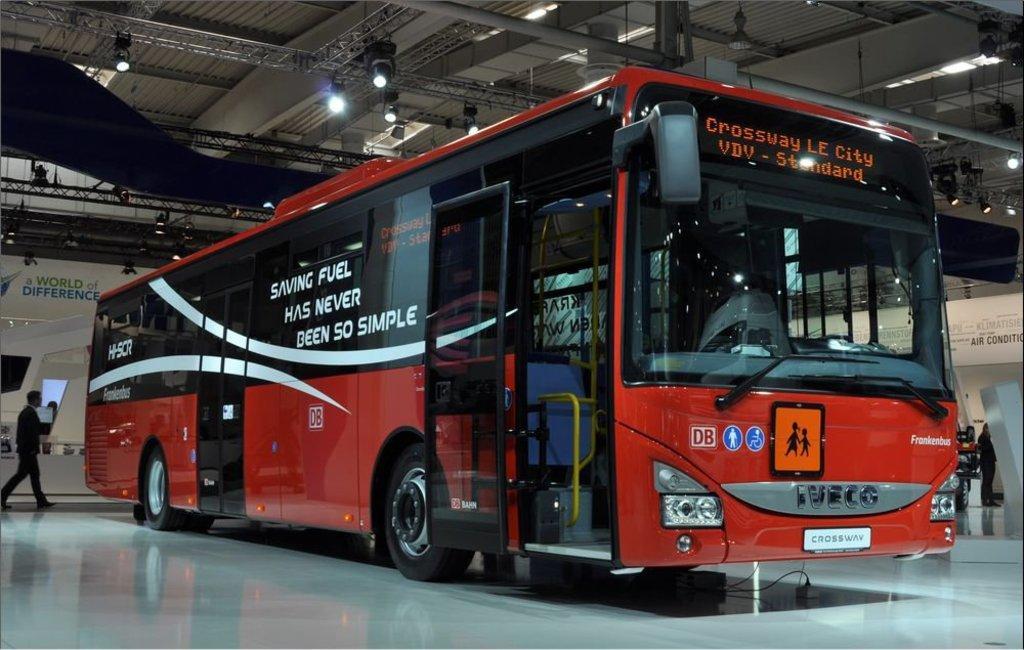Could you give a brief overview of what you see in this image? In this picture I can see there is a red color bus parked here and there are two doors, windows, windshield, screen, mirrors and there is a person on the left side. There is an iron frame on the ceiling and there are lights attached to the ceiling. 